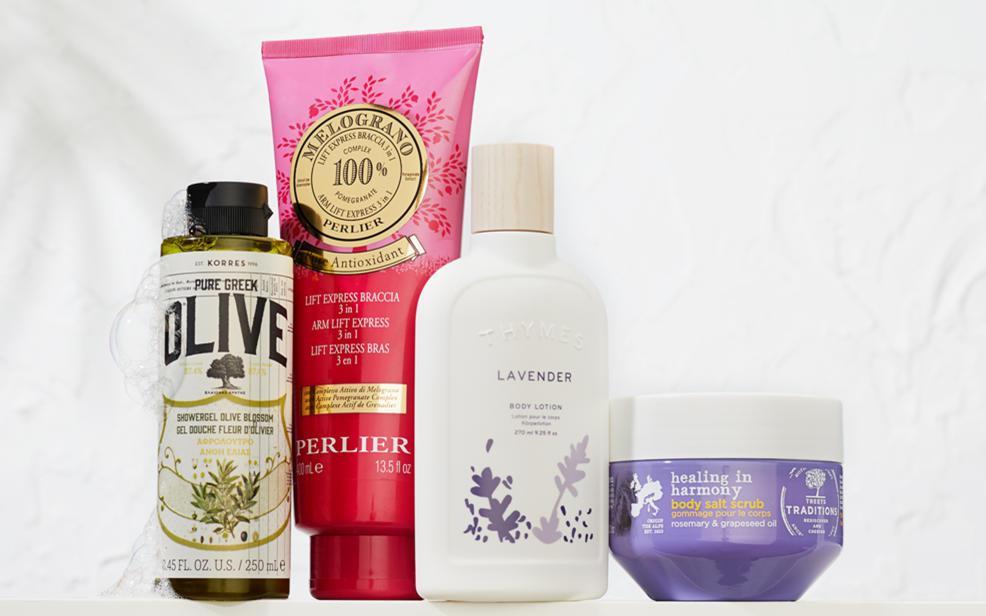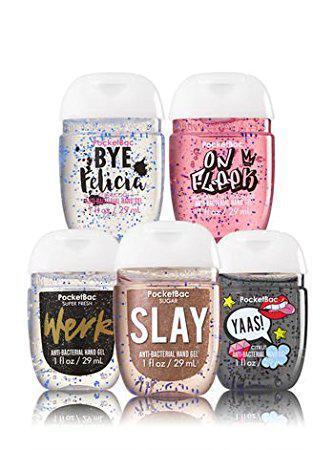The first image is the image on the left, the second image is the image on the right. For the images shown, is this caption "There are exactly two objects standing." true? Answer yes or no. No. 